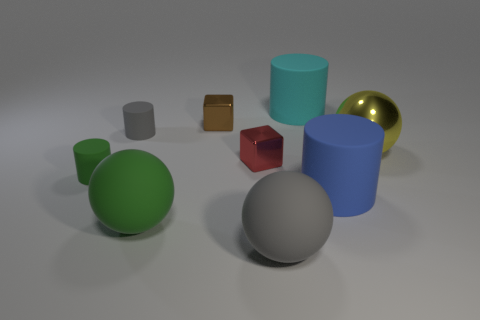Subtract all large yellow metallic spheres. How many spheres are left? 2 Subtract 0 purple cylinders. How many objects are left? 9 Subtract all cylinders. How many objects are left? 5 Subtract 2 blocks. How many blocks are left? 0 Subtract all cyan blocks. Subtract all brown cylinders. How many blocks are left? 2 Subtract all cyan cylinders. How many cyan cubes are left? 0 Subtract all large green matte things. Subtract all large spheres. How many objects are left? 5 Add 3 large green balls. How many large green balls are left? 4 Add 5 large gray matte things. How many large gray matte things exist? 6 Add 1 small gray cylinders. How many objects exist? 10 